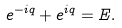<formula> <loc_0><loc_0><loc_500><loc_500>e ^ { - i q } + e ^ { i q } = E .</formula> 